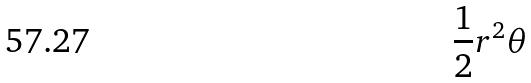<formula> <loc_0><loc_0><loc_500><loc_500>\frac { 1 } { 2 } r ^ { 2 } \theta</formula> 